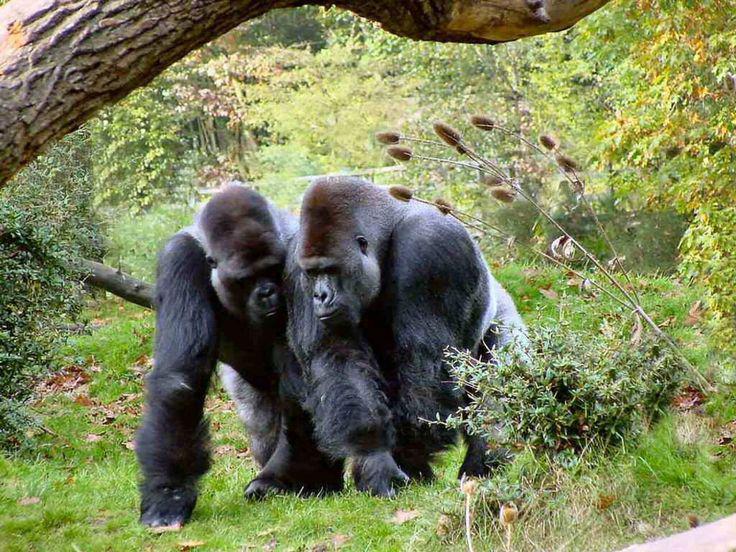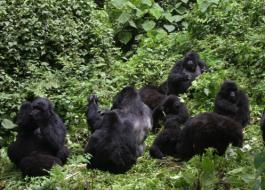The first image is the image on the left, the second image is the image on the right. Examine the images to the left and right. Is the description "One image contains at least three times the number of apes as the other image." accurate? Answer yes or no. Yes. The first image is the image on the left, the second image is the image on the right. Considering the images on both sides, is "On one image, a baby gorilla is perched on a bigger gorilla." valid? Answer yes or no. No. 